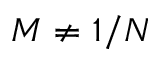Convert formula to latex. <formula><loc_0><loc_0><loc_500><loc_500>M \neq 1 / N</formula> 